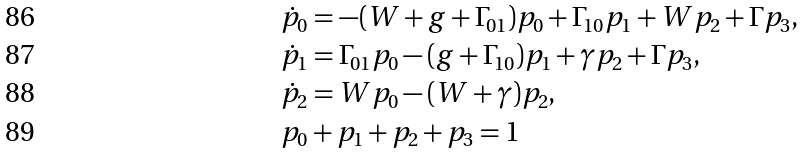Convert formula to latex. <formula><loc_0><loc_0><loc_500><loc_500>& \dot { p } _ { 0 } = - ( W + g + \Gamma _ { 0 1 } ) p _ { 0 } + \Gamma _ { 1 0 } p _ { 1 } + W p _ { 2 } + \Gamma p _ { 3 } , \\ & \dot { p } _ { 1 } = \Gamma _ { 0 1 } p _ { 0 } - ( g + \Gamma _ { 1 0 } ) p _ { 1 } + \gamma p _ { 2 } + \Gamma p _ { 3 } , \\ & \dot { p } _ { 2 } = W p _ { 0 } - ( W + \gamma ) p _ { 2 } , \\ & p _ { 0 } + p _ { 1 } + p _ { 2 } + p _ { 3 } = 1</formula> 